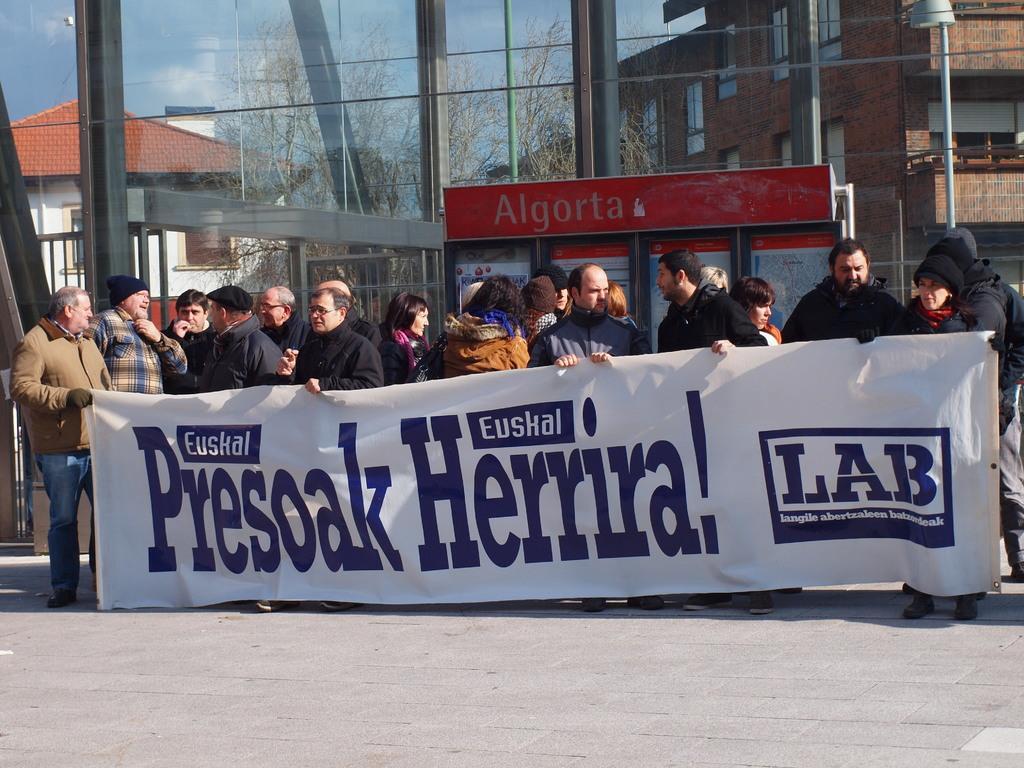Can you describe this image briefly? In the center of the image we can see a few people are standing and they are in different costumes. Among them, we can see a few people are holding a banner. On the banner, we can see some text. In the background, we can see the sky, trees, buildings, windows, banners and one pole. 